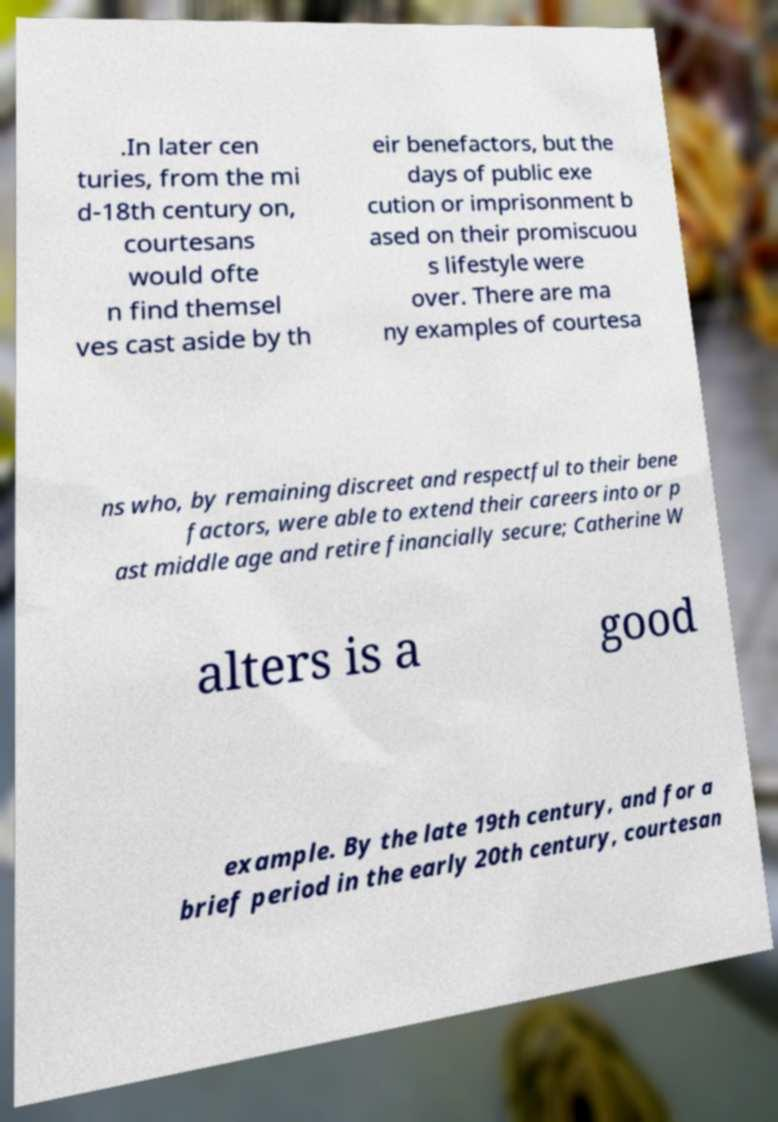What messages or text are displayed in this image? I need them in a readable, typed format. .In later cen turies, from the mi d-18th century on, courtesans would ofte n find themsel ves cast aside by th eir benefactors, but the days of public exe cution or imprisonment b ased on their promiscuou s lifestyle were over. There are ma ny examples of courtesa ns who, by remaining discreet and respectful to their bene factors, were able to extend their careers into or p ast middle age and retire financially secure; Catherine W alters is a good example. By the late 19th century, and for a brief period in the early 20th century, courtesan 